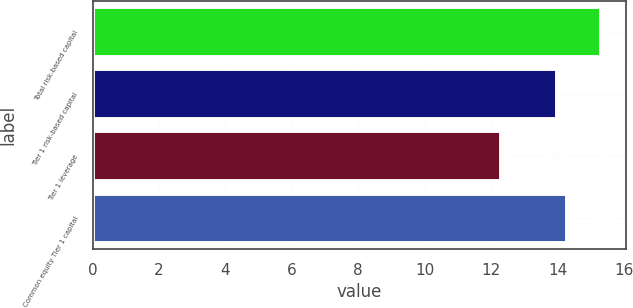Convert chart. <chart><loc_0><loc_0><loc_500><loc_500><bar_chart><fcel>Total risk-based capital<fcel>Tier 1 risk-based capital<fcel>Tier 1 leverage<fcel>Common equity Tier 1 capital<nl><fcel>15.3<fcel>14<fcel>12.3<fcel>14.3<nl></chart> 